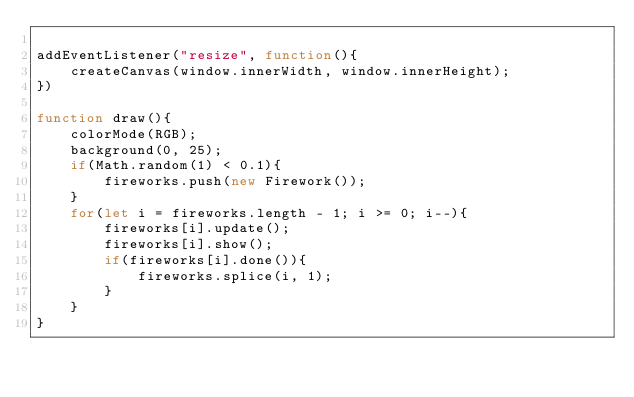Convert code to text. <code><loc_0><loc_0><loc_500><loc_500><_JavaScript_>
addEventListener("resize", function(){
    createCanvas(window.innerWidth, window.innerHeight);
})

function draw(){
    colorMode(RGB);
    background(0, 25);
    if(Math.random(1) < 0.1){
        fireworks.push(new Firework());
    }
    for(let i = fireworks.length - 1; i >= 0; i--){
        fireworks[i].update();
        fireworks[i].show();
        if(fireworks[i].done()){
            fireworks.splice(i, 1);
        }
    }
}</code> 